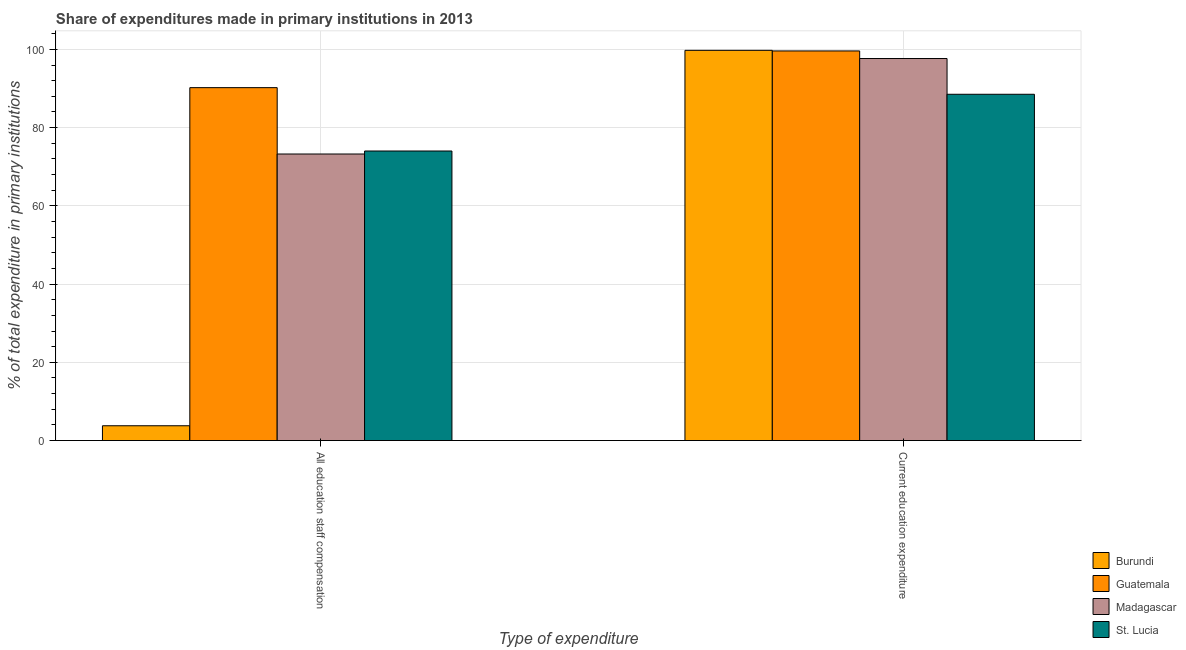How many different coloured bars are there?
Your answer should be very brief. 4. How many groups of bars are there?
Offer a very short reply. 2. How many bars are there on the 2nd tick from the left?
Offer a very short reply. 4. What is the label of the 2nd group of bars from the left?
Offer a terse response. Current education expenditure. What is the expenditure in staff compensation in Burundi?
Your answer should be very brief. 3.79. Across all countries, what is the maximum expenditure in staff compensation?
Offer a very short reply. 90.22. Across all countries, what is the minimum expenditure in staff compensation?
Provide a short and direct response. 3.79. In which country was the expenditure in staff compensation maximum?
Your answer should be very brief. Guatemala. In which country was the expenditure in staff compensation minimum?
Ensure brevity in your answer.  Burundi. What is the total expenditure in staff compensation in the graph?
Provide a short and direct response. 241.28. What is the difference between the expenditure in staff compensation in Madagascar and that in St. Lucia?
Your answer should be compact. -0.77. What is the difference between the expenditure in education in Madagascar and the expenditure in staff compensation in St. Lucia?
Ensure brevity in your answer.  23.64. What is the average expenditure in staff compensation per country?
Give a very brief answer. 60.32. What is the difference between the expenditure in education and expenditure in staff compensation in St. Lucia?
Keep it short and to the point. 14.5. What is the ratio of the expenditure in education in Madagascar to that in Burundi?
Offer a terse response. 0.98. Is the expenditure in staff compensation in St. Lucia less than that in Guatemala?
Give a very brief answer. Yes. What does the 2nd bar from the left in Current education expenditure represents?
Offer a terse response. Guatemala. What does the 2nd bar from the right in All education staff compensation represents?
Provide a succinct answer. Madagascar. How many countries are there in the graph?
Offer a very short reply. 4. Are the values on the major ticks of Y-axis written in scientific E-notation?
Make the answer very short. No. How are the legend labels stacked?
Offer a very short reply. Vertical. What is the title of the graph?
Provide a succinct answer. Share of expenditures made in primary institutions in 2013. Does "Saudi Arabia" appear as one of the legend labels in the graph?
Offer a very short reply. No. What is the label or title of the X-axis?
Provide a succinct answer. Type of expenditure. What is the label or title of the Y-axis?
Provide a succinct answer. % of total expenditure in primary institutions. What is the % of total expenditure in primary institutions of Burundi in All education staff compensation?
Give a very brief answer. 3.79. What is the % of total expenditure in primary institutions in Guatemala in All education staff compensation?
Offer a terse response. 90.22. What is the % of total expenditure in primary institutions in Madagascar in All education staff compensation?
Offer a terse response. 73.25. What is the % of total expenditure in primary institutions in St. Lucia in All education staff compensation?
Keep it short and to the point. 74.02. What is the % of total expenditure in primary institutions in Burundi in Current education expenditure?
Ensure brevity in your answer.  99.76. What is the % of total expenditure in primary institutions in Guatemala in Current education expenditure?
Provide a short and direct response. 99.6. What is the % of total expenditure in primary institutions of Madagascar in Current education expenditure?
Your answer should be compact. 97.66. What is the % of total expenditure in primary institutions in St. Lucia in Current education expenditure?
Provide a short and direct response. 88.53. Across all Type of expenditure, what is the maximum % of total expenditure in primary institutions of Burundi?
Make the answer very short. 99.76. Across all Type of expenditure, what is the maximum % of total expenditure in primary institutions of Guatemala?
Provide a succinct answer. 99.6. Across all Type of expenditure, what is the maximum % of total expenditure in primary institutions in Madagascar?
Provide a succinct answer. 97.66. Across all Type of expenditure, what is the maximum % of total expenditure in primary institutions in St. Lucia?
Give a very brief answer. 88.53. Across all Type of expenditure, what is the minimum % of total expenditure in primary institutions in Burundi?
Ensure brevity in your answer.  3.79. Across all Type of expenditure, what is the minimum % of total expenditure in primary institutions in Guatemala?
Provide a succinct answer. 90.22. Across all Type of expenditure, what is the minimum % of total expenditure in primary institutions in Madagascar?
Give a very brief answer. 73.25. Across all Type of expenditure, what is the minimum % of total expenditure in primary institutions in St. Lucia?
Offer a terse response. 74.02. What is the total % of total expenditure in primary institutions of Burundi in the graph?
Give a very brief answer. 103.54. What is the total % of total expenditure in primary institutions of Guatemala in the graph?
Keep it short and to the point. 189.82. What is the total % of total expenditure in primary institutions of Madagascar in the graph?
Offer a very short reply. 170.91. What is the total % of total expenditure in primary institutions of St. Lucia in the graph?
Provide a succinct answer. 162.55. What is the difference between the % of total expenditure in primary institutions of Burundi in All education staff compensation and that in Current education expenditure?
Offer a very short reply. -95.97. What is the difference between the % of total expenditure in primary institutions in Guatemala in All education staff compensation and that in Current education expenditure?
Offer a very short reply. -9.38. What is the difference between the % of total expenditure in primary institutions in Madagascar in All education staff compensation and that in Current education expenditure?
Your answer should be compact. -24.41. What is the difference between the % of total expenditure in primary institutions of St. Lucia in All education staff compensation and that in Current education expenditure?
Your answer should be very brief. -14.5. What is the difference between the % of total expenditure in primary institutions of Burundi in All education staff compensation and the % of total expenditure in primary institutions of Guatemala in Current education expenditure?
Your response must be concise. -95.81. What is the difference between the % of total expenditure in primary institutions of Burundi in All education staff compensation and the % of total expenditure in primary institutions of Madagascar in Current education expenditure?
Provide a succinct answer. -93.87. What is the difference between the % of total expenditure in primary institutions in Burundi in All education staff compensation and the % of total expenditure in primary institutions in St. Lucia in Current education expenditure?
Your response must be concise. -84.74. What is the difference between the % of total expenditure in primary institutions in Guatemala in All education staff compensation and the % of total expenditure in primary institutions in Madagascar in Current education expenditure?
Make the answer very short. -7.44. What is the difference between the % of total expenditure in primary institutions in Guatemala in All education staff compensation and the % of total expenditure in primary institutions in St. Lucia in Current education expenditure?
Your answer should be compact. 1.69. What is the difference between the % of total expenditure in primary institutions in Madagascar in All education staff compensation and the % of total expenditure in primary institutions in St. Lucia in Current education expenditure?
Your answer should be compact. -15.27. What is the average % of total expenditure in primary institutions in Burundi per Type of expenditure?
Provide a short and direct response. 51.77. What is the average % of total expenditure in primary institutions of Guatemala per Type of expenditure?
Offer a terse response. 94.91. What is the average % of total expenditure in primary institutions in Madagascar per Type of expenditure?
Your answer should be very brief. 85.46. What is the average % of total expenditure in primary institutions in St. Lucia per Type of expenditure?
Your response must be concise. 81.27. What is the difference between the % of total expenditure in primary institutions in Burundi and % of total expenditure in primary institutions in Guatemala in All education staff compensation?
Your response must be concise. -86.43. What is the difference between the % of total expenditure in primary institutions of Burundi and % of total expenditure in primary institutions of Madagascar in All education staff compensation?
Ensure brevity in your answer.  -69.46. What is the difference between the % of total expenditure in primary institutions in Burundi and % of total expenditure in primary institutions in St. Lucia in All education staff compensation?
Your answer should be very brief. -70.23. What is the difference between the % of total expenditure in primary institutions in Guatemala and % of total expenditure in primary institutions in Madagascar in All education staff compensation?
Offer a very short reply. 16.96. What is the difference between the % of total expenditure in primary institutions in Guatemala and % of total expenditure in primary institutions in St. Lucia in All education staff compensation?
Ensure brevity in your answer.  16.2. What is the difference between the % of total expenditure in primary institutions of Madagascar and % of total expenditure in primary institutions of St. Lucia in All education staff compensation?
Offer a terse response. -0.77. What is the difference between the % of total expenditure in primary institutions in Burundi and % of total expenditure in primary institutions in Guatemala in Current education expenditure?
Offer a very short reply. 0.15. What is the difference between the % of total expenditure in primary institutions of Burundi and % of total expenditure in primary institutions of Madagascar in Current education expenditure?
Keep it short and to the point. 2.09. What is the difference between the % of total expenditure in primary institutions of Burundi and % of total expenditure in primary institutions of St. Lucia in Current education expenditure?
Make the answer very short. 11.23. What is the difference between the % of total expenditure in primary institutions of Guatemala and % of total expenditure in primary institutions of Madagascar in Current education expenditure?
Make the answer very short. 1.94. What is the difference between the % of total expenditure in primary institutions in Guatemala and % of total expenditure in primary institutions in St. Lucia in Current education expenditure?
Offer a very short reply. 11.08. What is the difference between the % of total expenditure in primary institutions in Madagascar and % of total expenditure in primary institutions in St. Lucia in Current education expenditure?
Offer a very short reply. 9.14. What is the ratio of the % of total expenditure in primary institutions of Burundi in All education staff compensation to that in Current education expenditure?
Make the answer very short. 0.04. What is the ratio of the % of total expenditure in primary institutions of Guatemala in All education staff compensation to that in Current education expenditure?
Give a very brief answer. 0.91. What is the ratio of the % of total expenditure in primary institutions of Madagascar in All education staff compensation to that in Current education expenditure?
Provide a short and direct response. 0.75. What is the ratio of the % of total expenditure in primary institutions in St. Lucia in All education staff compensation to that in Current education expenditure?
Offer a terse response. 0.84. What is the difference between the highest and the second highest % of total expenditure in primary institutions in Burundi?
Offer a very short reply. 95.97. What is the difference between the highest and the second highest % of total expenditure in primary institutions of Guatemala?
Your answer should be very brief. 9.38. What is the difference between the highest and the second highest % of total expenditure in primary institutions in Madagascar?
Offer a very short reply. 24.41. What is the difference between the highest and the second highest % of total expenditure in primary institutions of St. Lucia?
Offer a very short reply. 14.5. What is the difference between the highest and the lowest % of total expenditure in primary institutions in Burundi?
Give a very brief answer. 95.97. What is the difference between the highest and the lowest % of total expenditure in primary institutions of Guatemala?
Provide a short and direct response. 9.38. What is the difference between the highest and the lowest % of total expenditure in primary institutions of Madagascar?
Your response must be concise. 24.41. What is the difference between the highest and the lowest % of total expenditure in primary institutions of St. Lucia?
Provide a succinct answer. 14.5. 